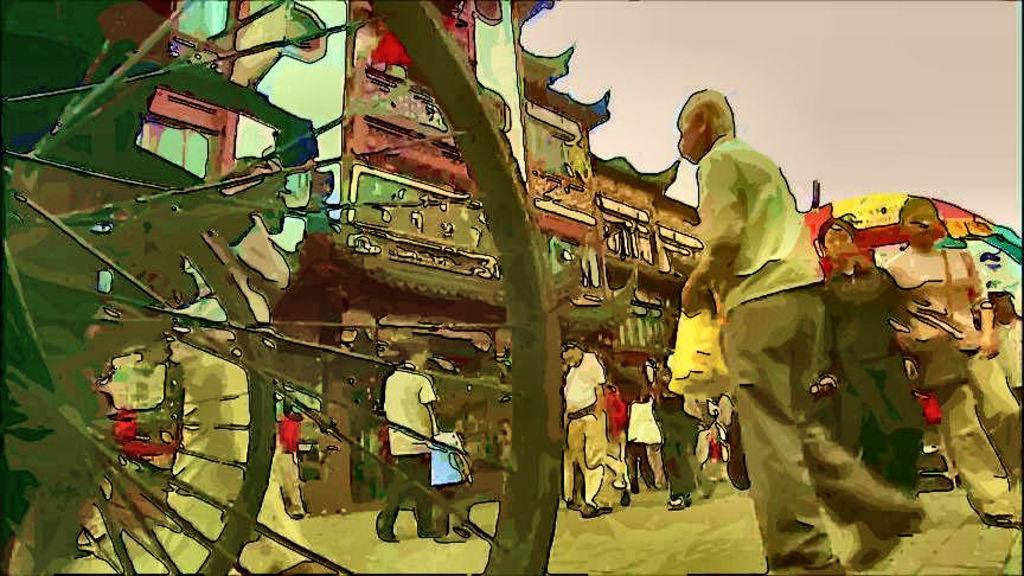How would you summarize this image in a sentence or two? Here we can see a edited picture, in this we can find few people and buildings. 